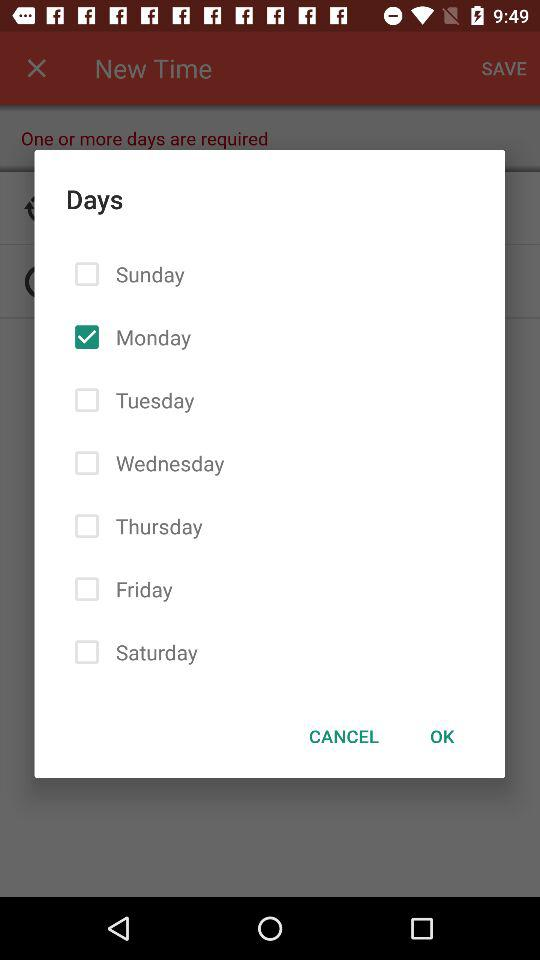What are the options available in the list? The options available in the list are "Sunday", "Monday", "Tuesday", "Wednesday", "Thursday", "Friday" and "Saturday". 